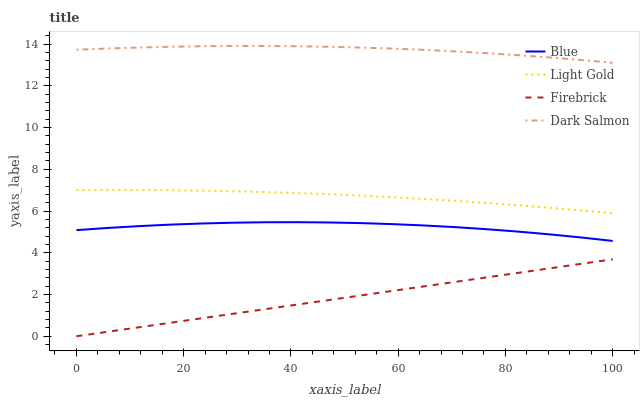Does Light Gold have the minimum area under the curve?
Answer yes or no. No. Does Light Gold have the maximum area under the curve?
Answer yes or no. No. Is Light Gold the smoothest?
Answer yes or no. No. Is Light Gold the roughest?
Answer yes or no. No. Does Light Gold have the lowest value?
Answer yes or no. No. Does Light Gold have the highest value?
Answer yes or no. No. Is Firebrick less than Dark Salmon?
Answer yes or no. Yes. Is Light Gold greater than Blue?
Answer yes or no. Yes. Does Firebrick intersect Dark Salmon?
Answer yes or no. No. 